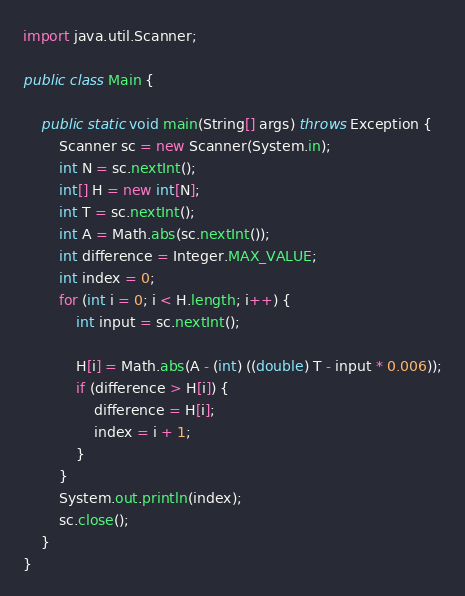<code> <loc_0><loc_0><loc_500><loc_500><_Java_>import java.util.Scanner;

public class Main {

	public static void main(String[] args) throws Exception {
		Scanner sc = new Scanner(System.in);
		int N = sc.nextInt();
		int[] H = new int[N];
		int T = sc.nextInt();
		int A = Math.abs(sc.nextInt());
		int difference = Integer.MAX_VALUE;
		int index = 0;
		for (int i = 0; i < H.length; i++) {
			int input = sc.nextInt();

			H[i] = Math.abs(A - (int) ((double) T - input * 0.006));
			if (difference > H[i]) {
				difference = H[i];
				index = i + 1;
			}
		}
		System.out.println(index);
		sc.close();
	}
}</code> 